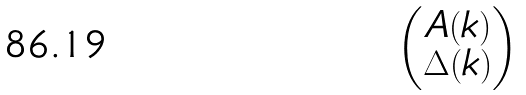<formula> <loc_0><loc_0><loc_500><loc_500>\begin{pmatrix} A ( k ) \\ \Delta ( k ) \end{pmatrix}</formula> 